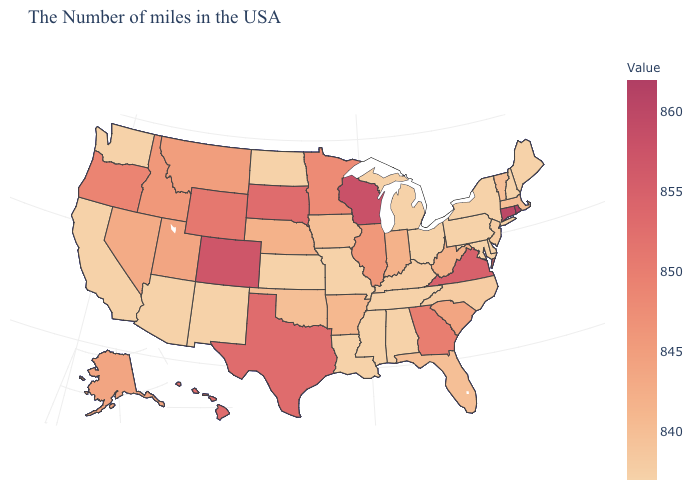Among the states that border New York , which have the highest value?
Short answer required. Connecticut. Does Delaware have the lowest value in the USA?
Write a very short answer. Yes. Among the states that border Rhode Island , does Massachusetts have the lowest value?
Concise answer only. Yes. Does Alaska have the lowest value in the West?
Answer briefly. No. Among the states that border Maryland , does Delaware have the lowest value?
Quick response, please. Yes. Is the legend a continuous bar?
Answer briefly. Yes. Among the states that border Florida , does Alabama have the lowest value?
Answer briefly. Yes. Which states hav the highest value in the MidWest?
Write a very short answer. Wisconsin. 